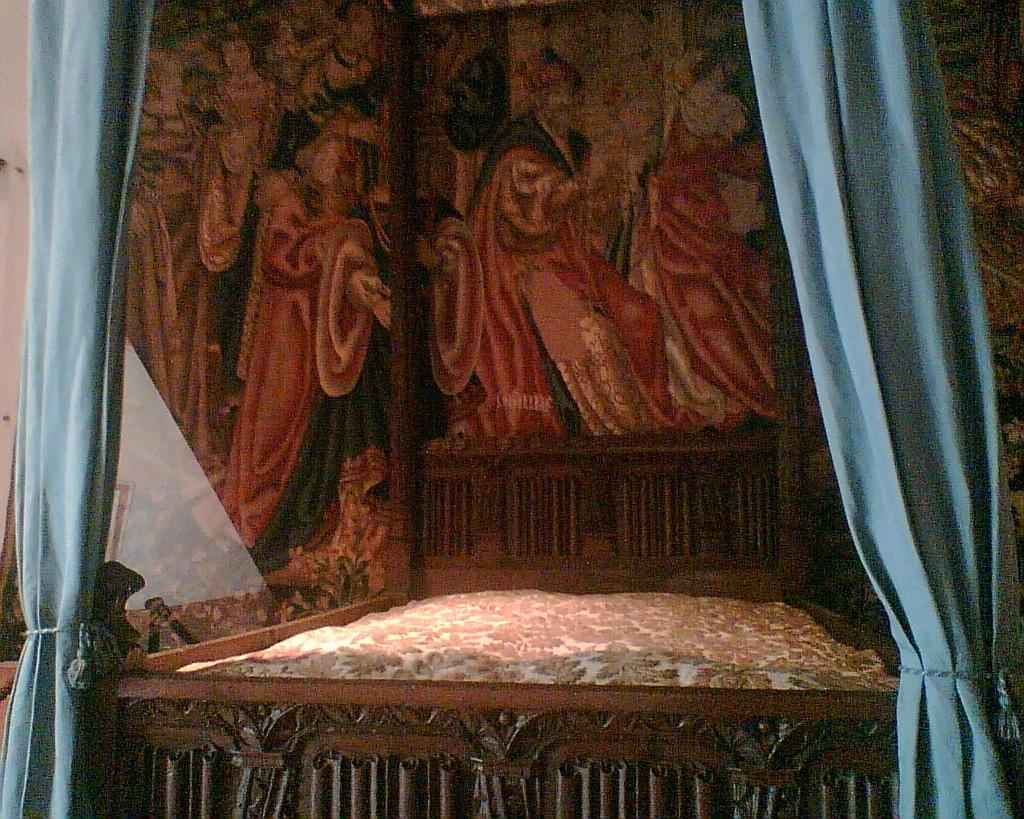What piece of furniture is present in the image? There is a bed in the image. What is on top of the bed? The bed has a mattress on it. What color are the curtains in the image? There are blue color curtains in the image. What can be seen on the wall in the background? There is a painting of people on the wall in the background, and there are other things visible on the wall as well. Can you see any clouds or shade in the image? There are no clouds or shade visible in the image, as it is an indoor scene with no windows or outdoor elements. 